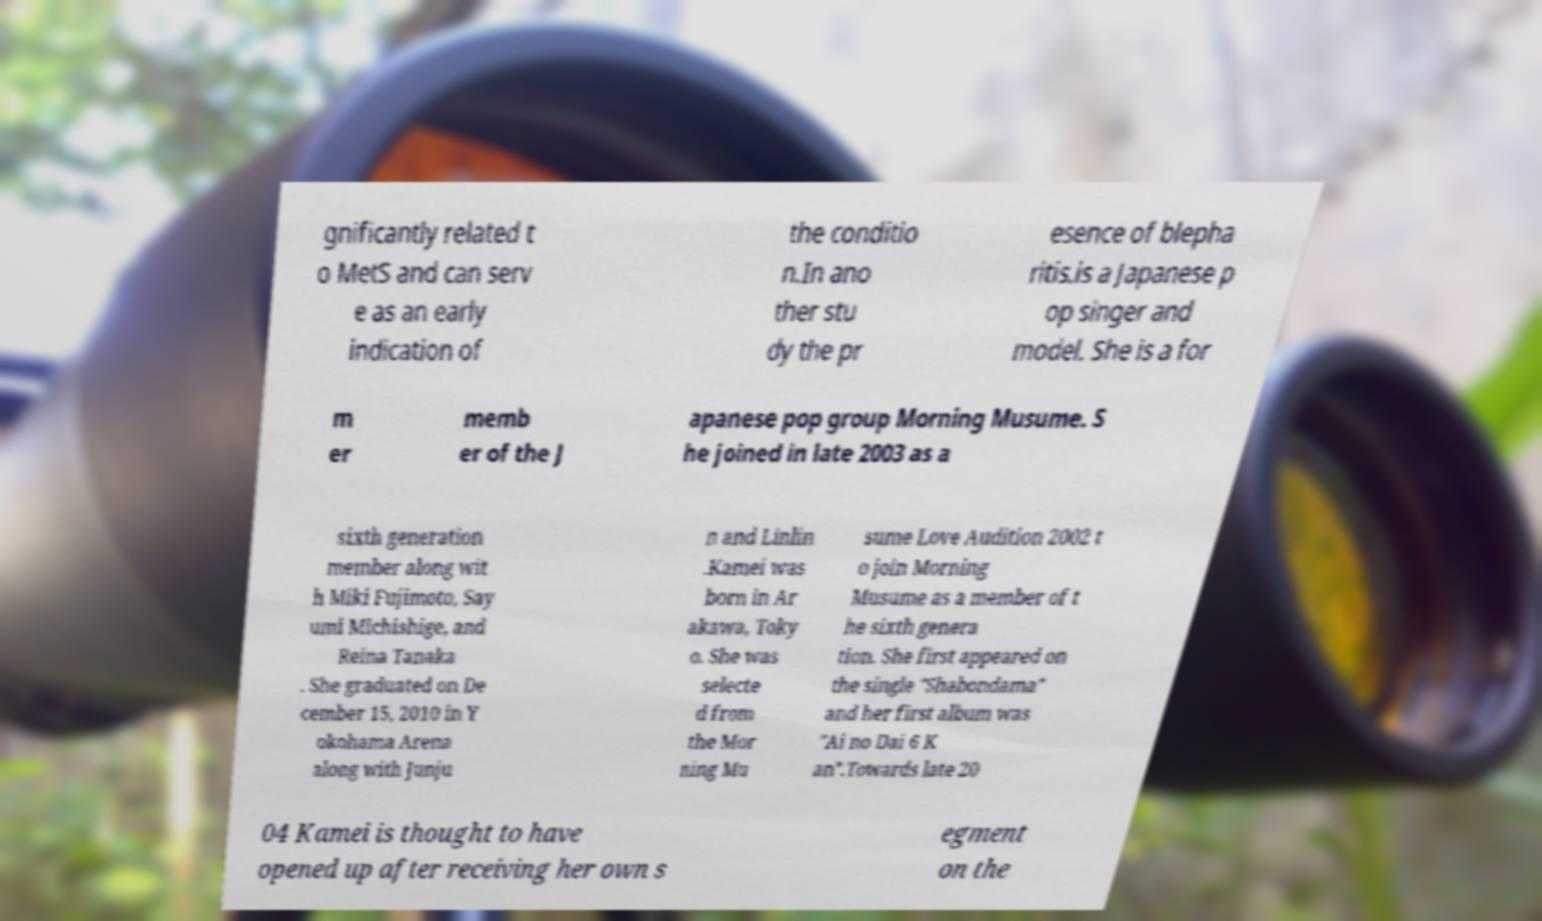Could you extract and type out the text from this image? gnificantly related t o MetS and can serv e as an early indication of the conditio n.In ano ther stu dy the pr esence of blepha ritis.is a Japanese p op singer and model. She is a for m er memb er of the J apanese pop group Morning Musume. S he joined in late 2003 as a sixth generation member along wit h Miki Fujimoto, Say umi Michishige, and Reina Tanaka . She graduated on De cember 15, 2010 in Y okohama Arena along with Junju n and Linlin .Kamei was born in Ar akawa, Toky o. She was selecte d from the Mor ning Mu sume Love Audition 2002 t o join Morning Musume as a member of t he sixth genera tion. She first appeared on the single "Shabondama" and her first album was "Ai no Dai 6 K an".Towards late 20 04 Kamei is thought to have opened up after receiving her own s egment on the 